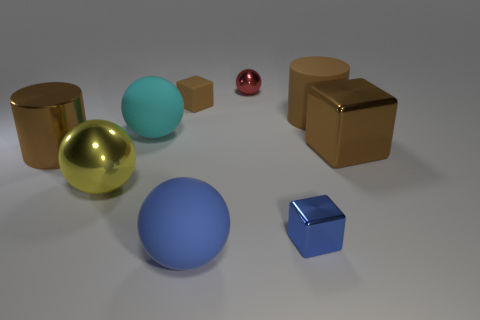Is there any object that stands out in terms of its color or size? The small red sphere stands out due to its vibrant color and smaller size compared to the other objects in the image. 